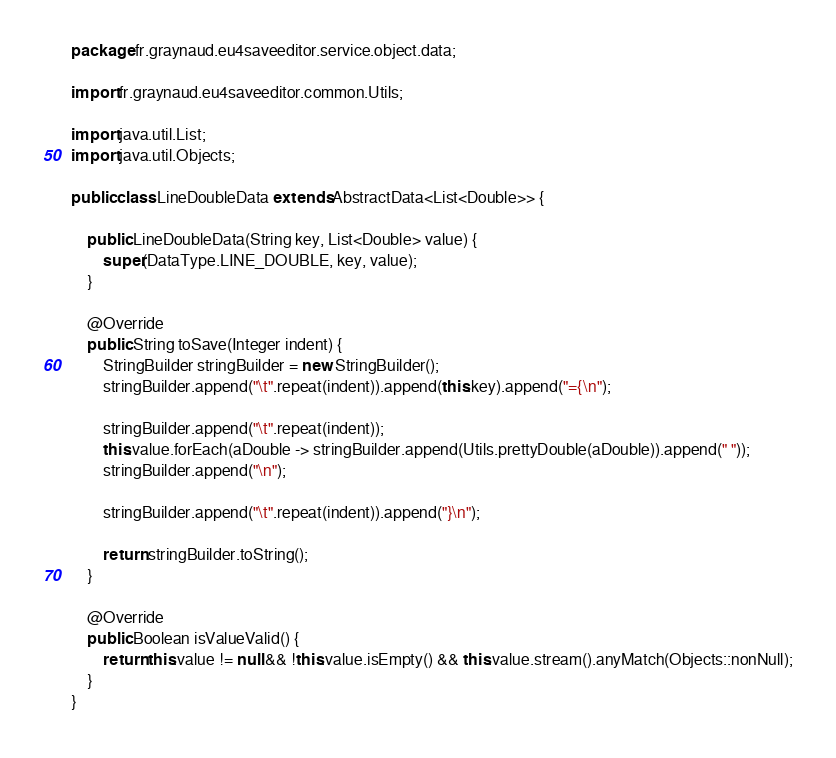<code> <loc_0><loc_0><loc_500><loc_500><_Java_>package fr.graynaud.eu4saveeditor.service.object.data;

import fr.graynaud.eu4saveeditor.common.Utils;

import java.util.List;
import java.util.Objects;

public class LineDoubleData extends AbstractData<List<Double>> {

    public LineDoubleData(String key, List<Double> value) {
        super(DataType.LINE_DOUBLE, key, value);
    }

    @Override
    public String toSave(Integer indent) {
        StringBuilder stringBuilder = new StringBuilder();
        stringBuilder.append("\t".repeat(indent)).append(this.key).append("={\n");

        stringBuilder.append("\t".repeat(indent));
        this.value.forEach(aDouble -> stringBuilder.append(Utils.prettyDouble(aDouble)).append(" "));
        stringBuilder.append("\n");

        stringBuilder.append("\t".repeat(indent)).append("}\n");

        return stringBuilder.toString();
    }

    @Override
    public Boolean isValueValid() {
        return this.value != null && !this.value.isEmpty() && this.value.stream().anyMatch(Objects::nonNull);
    }
}
</code> 